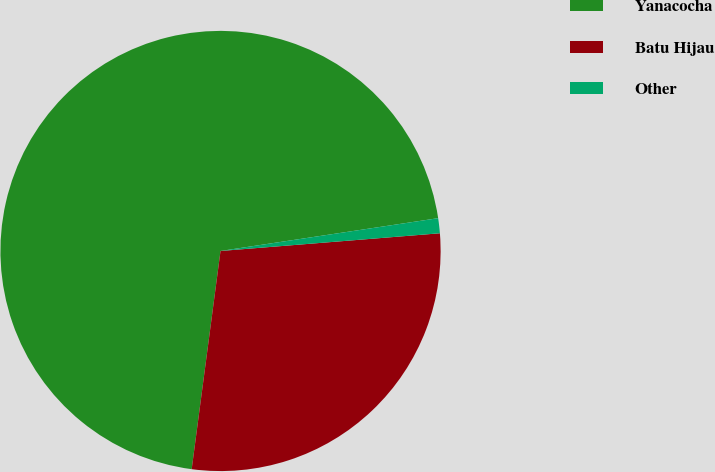Convert chart. <chart><loc_0><loc_0><loc_500><loc_500><pie_chart><fcel>Yanacocha<fcel>Batu Hijau<fcel>Other<nl><fcel>70.52%<fcel>28.37%<fcel>1.1%<nl></chart> 